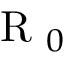Convert formula to latex. <formula><loc_0><loc_0><loc_500><loc_500>R _ { 0 }</formula> 